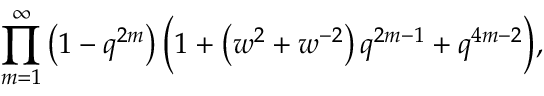<formula> <loc_0><loc_0><loc_500><loc_500>\prod _ { m = 1 } ^ { \infty } \left ( 1 - q ^ { 2 m } \right ) { \left ( } 1 + \left ( w ^ { 2 } + w ^ { - 2 } \right ) q ^ { 2 m - 1 } + q ^ { 4 m - 2 } { \right ) } ,</formula> 